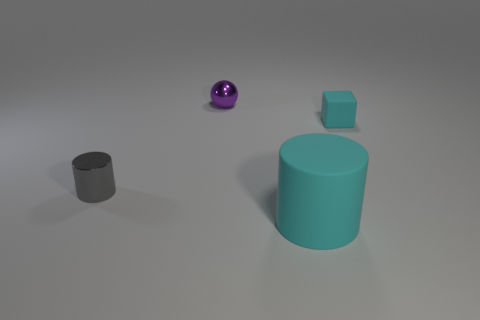Add 2 tiny green matte objects. How many objects exist? 6 Subtract all cubes. How many objects are left? 3 Add 1 tiny yellow metallic cylinders. How many tiny yellow metallic cylinders exist? 1 Subtract 0 green balls. How many objects are left? 4 Subtract all purple shiny things. Subtract all big matte things. How many objects are left? 2 Add 4 matte cubes. How many matte cubes are left? 5 